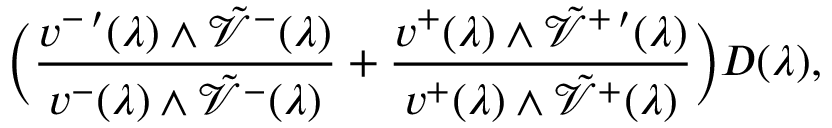Convert formula to latex. <formula><loc_0><loc_0><loc_500><loc_500>\left ( \frac { v ^ { - \, \prime } ( \lambda ) \wedge \tilde { \mathcal { V } } ^ { - } ( \lambda ) } { v ^ { - } ( \lambda ) \wedge \tilde { \mathcal { V } } ^ { - } ( \lambda ) } + \frac { v ^ { + } ( \lambda ) \wedge \tilde { \mathcal { V } } ^ { + \, \prime } ( \lambda ) } { v ^ { + } ( \lambda ) \wedge \tilde { \mathcal { V } } ^ { + } ( \lambda ) } \right ) D ( \lambda ) ,</formula> 